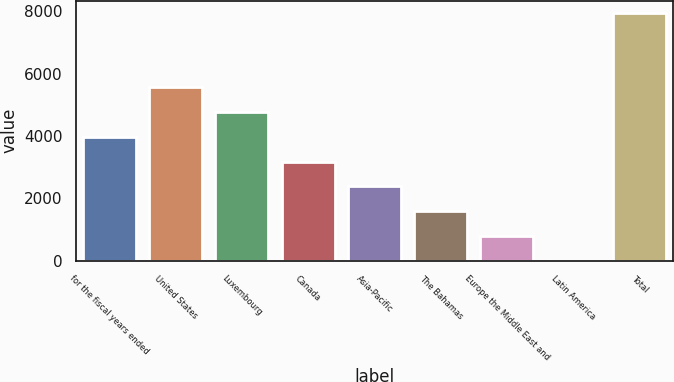Convert chart. <chart><loc_0><loc_0><loc_500><loc_500><bar_chart><fcel>for the fiscal years ended<fcel>United States<fcel>Luxembourg<fcel>Canada<fcel>Asia-Pacific<fcel>The Bahamas<fcel>Europe the Middle East and<fcel>Latin America<fcel>Total<nl><fcel>3978.4<fcel>5566.52<fcel>4772.46<fcel>3184.34<fcel>2390.28<fcel>1596.22<fcel>802.16<fcel>8.1<fcel>7948.7<nl></chart> 